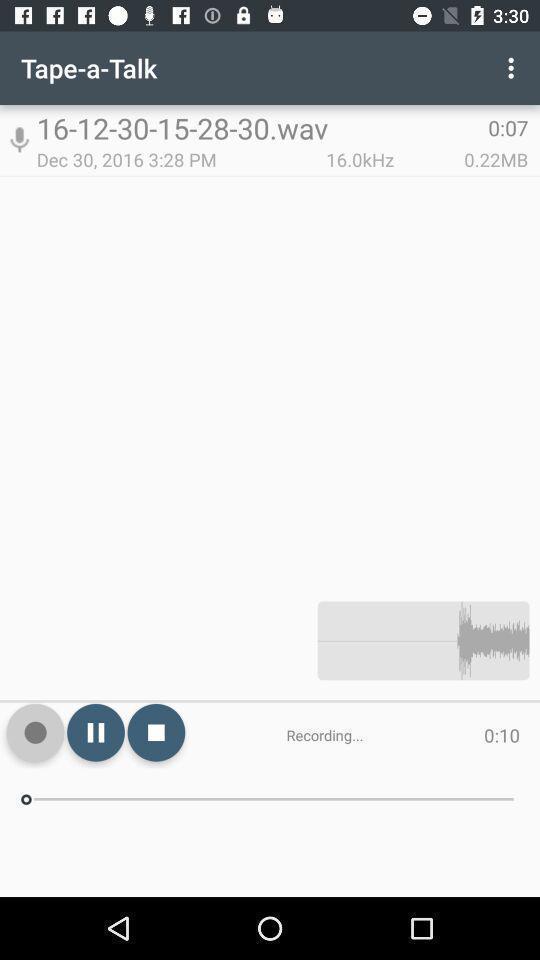Give me a summary of this screen capture. Screen shows a recording with options. 